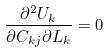<formula> <loc_0><loc_0><loc_500><loc_500>\frac { \partial ^ { 2 } U _ { k } } { \partial C _ { k j } \partial L _ { k } } = 0</formula> 